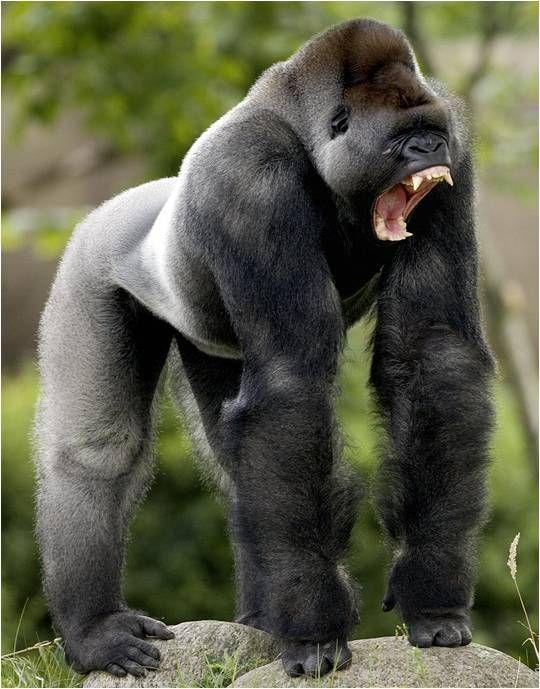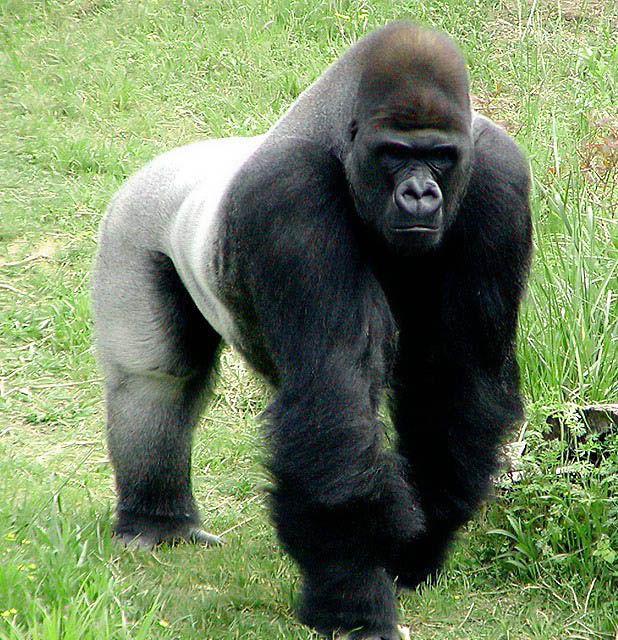The first image is the image on the left, the second image is the image on the right. Assess this claim about the two images: "Two gorillas are bent forward, standing on all four feet.". Correct or not? Answer yes or no. Yes. The first image is the image on the left, the second image is the image on the right. Given the left and right images, does the statement "All images show a gorilla standing on its legs and hands." hold true? Answer yes or no. Yes. 